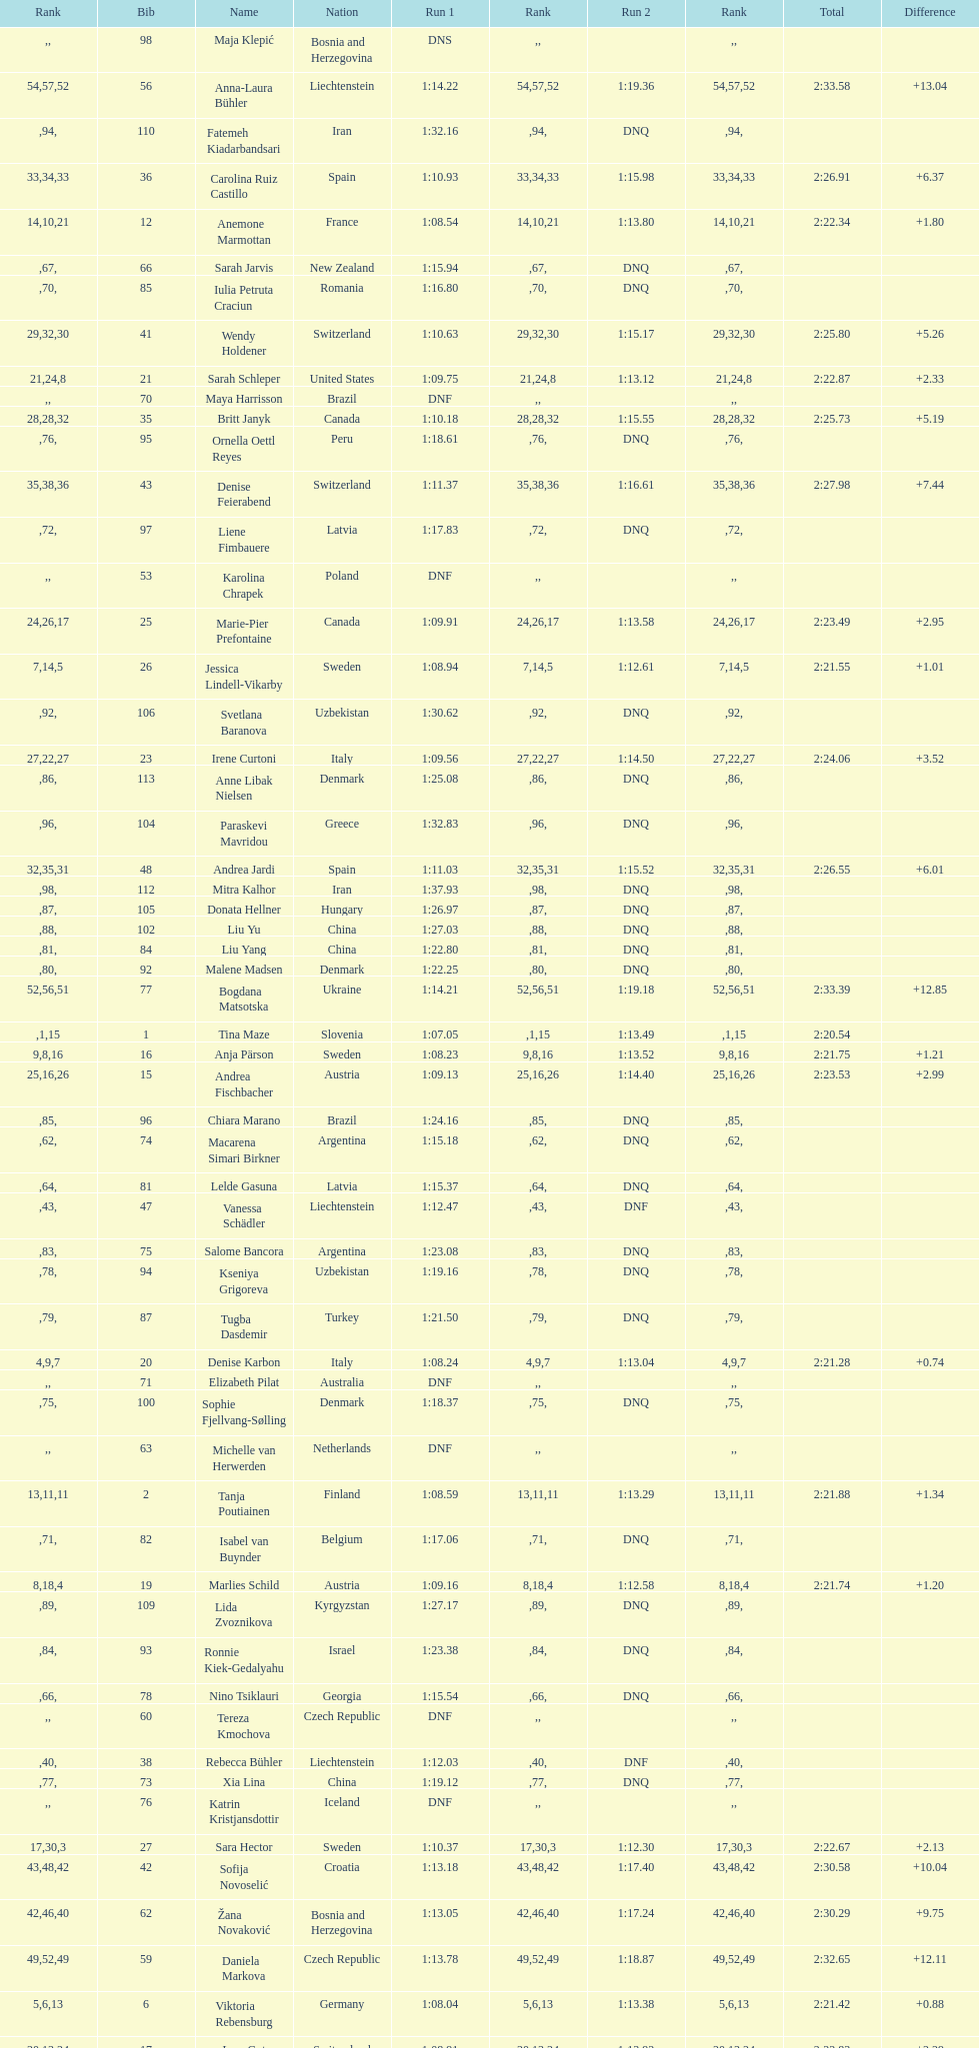What was the number of swedes in the top fifteen? 2. 